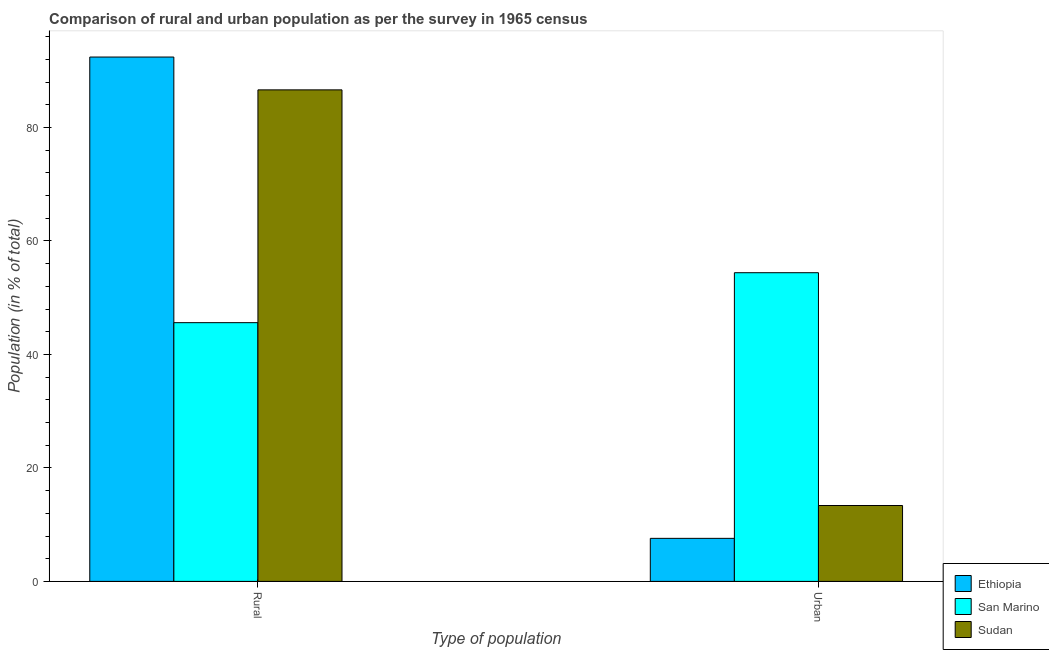How many different coloured bars are there?
Provide a succinct answer. 3. Are the number of bars on each tick of the X-axis equal?
Offer a very short reply. Yes. How many bars are there on the 1st tick from the left?
Provide a short and direct response. 3. How many bars are there on the 1st tick from the right?
Your response must be concise. 3. What is the label of the 2nd group of bars from the left?
Give a very brief answer. Urban. What is the rural population in San Marino?
Provide a succinct answer. 45.6. Across all countries, what is the maximum rural population?
Your response must be concise. 92.41. Across all countries, what is the minimum urban population?
Your answer should be very brief. 7.59. In which country was the rural population maximum?
Ensure brevity in your answer.  Ethiopia. In which country was the rural population minimum?
Provide a short and direct response. San Marino. What is the total rural population in the graph?
Provide a short and direct response. 224.64. What is the difference between the rural population in San Marino and that in Ethiopia?
Your answer should be compact. -46.81. What is the difference between the urban population in San Marino and the rural population in Sudan?
Your response must be concise. -32.23. What is the average rural population per country?
Your response must be concise. 74.88. What is the difference between the urban population and rural population in Ethiopia?
Ensure brevity in your answer.  -84.83. In how many countries, is the rural population greater than 92 %?
Keep it short and to the point. 1. What is the ratio of the rural population in Sudan to that in Ethiopia?
Your response must be concise. 0.94. What does the 2nd bar from the left in Urban represents?
Your answer should be compact. San Marino. What does the 1st bar from the right in Rural represents?
Provide a succinct answer. Sudan. Are all the bars in the graph horizontal?
Provide a succinct answer. No. How many countries are there in the graph?
Your response must be concise. 3. Does the graph contain any zero values?
Provide a succinct answer. No. Does the graph contain grids?
Keep it short and to the point. No. What is the title of the graph?
Your response must be concise. Comparison of rural and urban population as per the survey in 1965 census. What is the label or title of the X-axis?
Keep it short and to the point. Type of population. What is the label or title of the Y-axis?
Make the answer very short. Population (in % of total). What is the Population (in % of total) in Ethiopia in Rural?
Keep it short and to the point. 92.41. What is the Population (in % of total) in San Marino in Rural?
Keep it short and to the point. 45.6. What is the Population (in % of total) in Sudan in Rural?
Your response must be concise. 86.63. What is the Population (in % of total) in Ethiopia in Urban?
Ensure brevity in your answer.  7.59. What is the Population (in % of total) of San Marino in Urban?
Offer a very short reply. 54.4. What is the Population (in % of total) of Sudan in Urban?
Make the answer very short. 13.37. Across all Type of population, what is the maximum Population (in % of total) of Ethiopia?
Your response must be concise. 92.41. Across all Type of population, what is the maximum Population (in % of total) of San Marino?
Make the answer very short. 54.4. Across all Type of population, what is the maximum Population (in % of total) of Sudan?
Ensure brevity in your answer.  86.63. Across all Type of population, what is the minimum Population (in % of total) of Ethiopia?
Your answer should be very brief. 7.59. Across all Type of population, what is the minimum Population (in % of total) of San Marino?
Ensure brevity in your answer.  45.6. Across all Type of population, what is the minimum Population (in % of total) of Sudan?
Keep it short and to the point. 13.37. What is the total Population (in % of total) in Ethiopia in the graph?
Make the answer very short. 100. What is the total Population (in % of total) in San Marino in the graph?
Provide a short and direct response. 100. What is the difference between the Population (in % of total) of Ethiopia in Rural and that in Urban?
Your answer should be very brief. 84.83. What is the difference between the Population (in % of total) in San Marino in Rural and that in Urban?
Keep it short and to the point. -8.8. What is the difference between the Population (in % of total) in Sudan in Rural and that in Urban?
Offer a very short reply. 73.25. What is the difference between the Population (in % of total) of Ethiopia in Rural and the Population (in % of total) of San Marino in Urban?
Provide a succinct answer. 38.01. What is the difference between the Population (in % of total) in Ethiopia in Rural and the Population (in % of total) in Sudan in Urban?
Ensure brevity in your answer.  79.04. What is the difference between the Population (in % of total) of San Marino in Rural and the Population (in % of total) of Sudan in Urban?
Offer a terse response. 32.23. What is the average Population (in % of total) in San Marino per Type of population?
Keep it short and to the point. 50. What is the difference between the Population (in % of total) in Ethiopia and Population (in % of total) in San Marino in Rural?
Make the answer very short. 46.81. What is the difference between the Population (in % of total) of Ethiopia and Population (in % of total) of Sudan in Rural?
Keep it short and to the point. 5.79. What is the difference between the Population (in % of total) in San Marino and Population (in % of total) in Sudan in Rural?
Provide a short and direct response. -41.03. What is the difference between the Population (in % of total) in Ethiopia and Population (in % of total) in San Marino in Urban?
Offer a terse response. -46.81. What is the difference between the Population (in % of total) in Ethiopia and Population (in % of total) in Sudan in Urban?
Keep it short and to the point. -5.79. What is the difference between the Population (in % of total) of San Marino and Population (in % of total) of Sudan in Urban?
Give a very brief answer. 41.03. What is the ratio of the Population (in % of total) in Ethiopia in Rural to that in Urban?
Provide a succinct answer. 12.18. What is the ratio of the Population (in % of total) of San Marino in Rural to that in Urban?
Ensure brevity in your answer.  0.84. What is the ratio of the Population (in % of total) of Sudan in Rural to that in Urban?
Your answer should be compact. 6.48. What is the difference between the highest and the second highest Population (in % of total) in Ethiopia?
Your response must be concise. 84.83. What is the difference between the highest and the second highest Population (in % of total) in San Marino?
Your answer should be very brief. 8.8. What is the difference between the highest and the second highest Population (in % of total) in Sudan?
Provide a succinct answer. 73.25. What is the difference between the highest and the lowest Population (in % of total) in Ethiopia?
Provide a succinct answer. 84.83. What is the difference between the highest and the lowest Population (in % of total) of San Marino?
Keep it short and to the point. 8.8. What is the difference between the highest and the lowest Population (in % of total) of Sudan?
Your answer should be very brief. 73.25. 